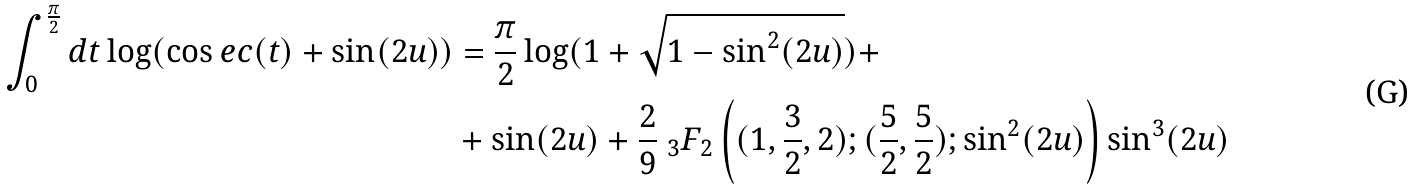<formula> <loc_0><loc_0><loc_500><loc_500>\int _ { 0 } ^ { \frac { \pi } { 2 } } d t \log ( \cos e c ( t ) + \sin ( 2 u ) ) & = \frac { \pi } { 2 } \log ( 1 + \sqrt { 1 - \sin ^ { 2 } ( 2 u ) } ) + \\ & + \sin ( 2 u ) + \frac { 2 } { 9 } \ _ { 3 } F _ { 2 } \left ( ( 1 , \frac { 3 } { 2 } , 2 ) ; ( \frac { 5 } { 2 } , \frac { 5 } { 2 } ) ; \sin ^ { 2 } ( 2 u ) \right ) \sin ^ { 3 } ( 2 u )</formula> 